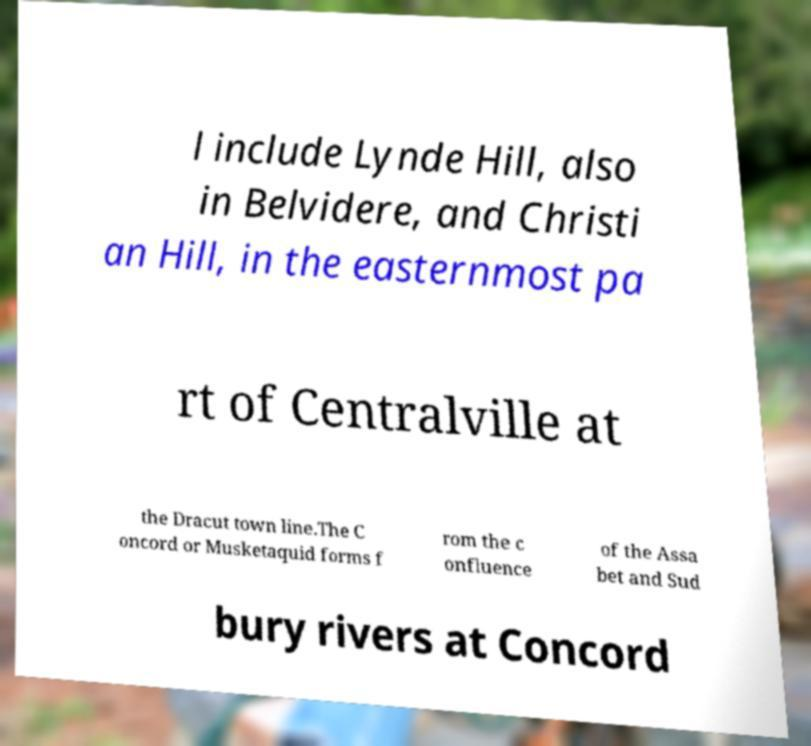For documentation purposes, I need the text within this image transcribed. Could you provide that? l include Lynde Hill, also in Belvidere, and Christi an Hill, in the easternmost pa rt of Centralville at the Dracut town line.The C oncord or Musketaquid forms f rom the c onfluence of the Assa bet and Sud bury rivers at Concord 